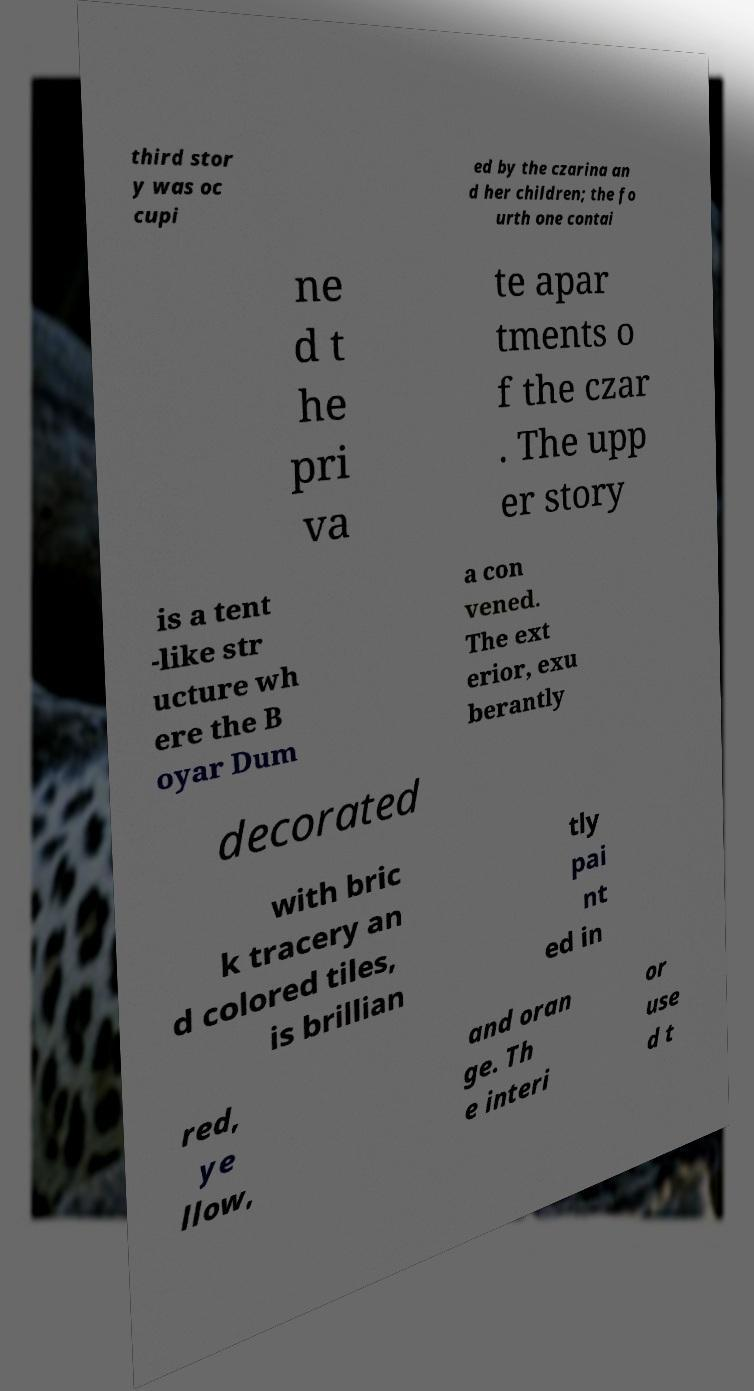What messages or text are displayed in this image? I need them in a readable, typed format. third stor y was oc cupi ed by the czarina an d her children; the fo urth one contai ne d t he pri va te apar tments o f the czar . The upp er story is a tent -like str ucture wh ere the B oyar Dum a con vened. The ext erior, exu berantly decorated with bric k tracery an d colored tiles, is brillian tly pai nt ed in red, ye llow, and oran ge. Th e interi or use d t 